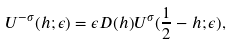Convert formula to latex. <formula><loc_0><loc_0><loc_500><loc_500>U ^ { - \sigma } ( h ; \epsilon ) = \epsilon D ( h ) U ^ { \sigma } ( \frac { 1 } { 2 } - h ; \epsilon ) ,</formula> 